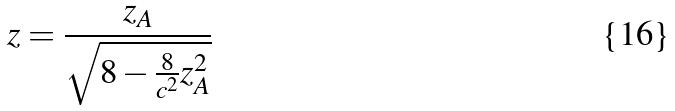<formula> <loc_0><loc_0><loc_500><loc_500>z = \frac { z _ { A } } { \sqrt { 8 - \frac { 8 } { c ^ { 2 } } z _ { A } ^ { 2 } } }</formula> 